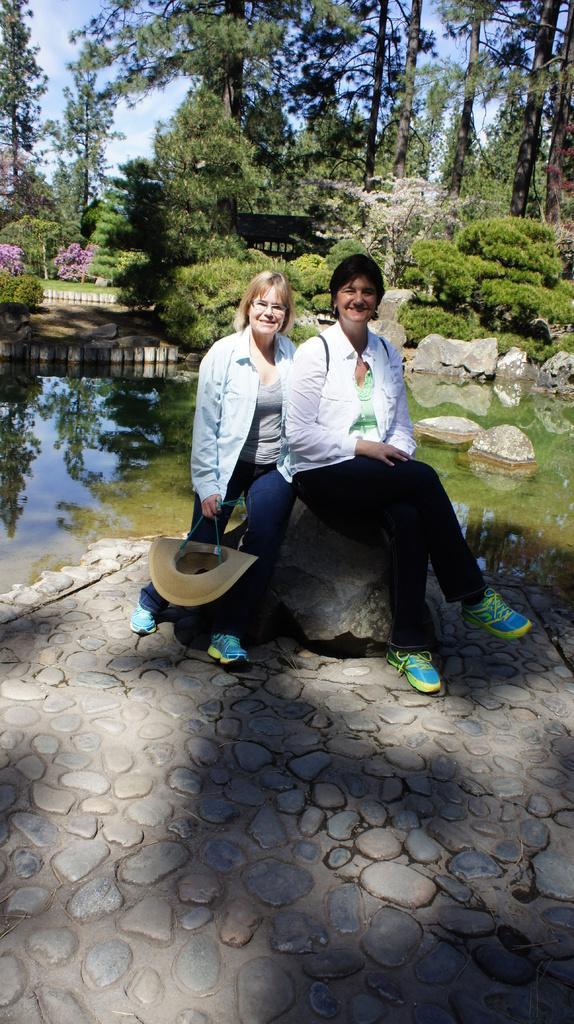Please provide a concise description of this image. There are two ladies sitting on a rock. Lady on the left is holding a hat. In the back there is water, rocks, bushes, trees and sky. 